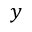<formula> <loc_0><loc_0><loc_500><loc_500>y</formula> 